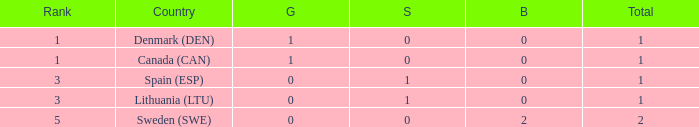What is the total when there were less than 0 bronze? 0.0. 